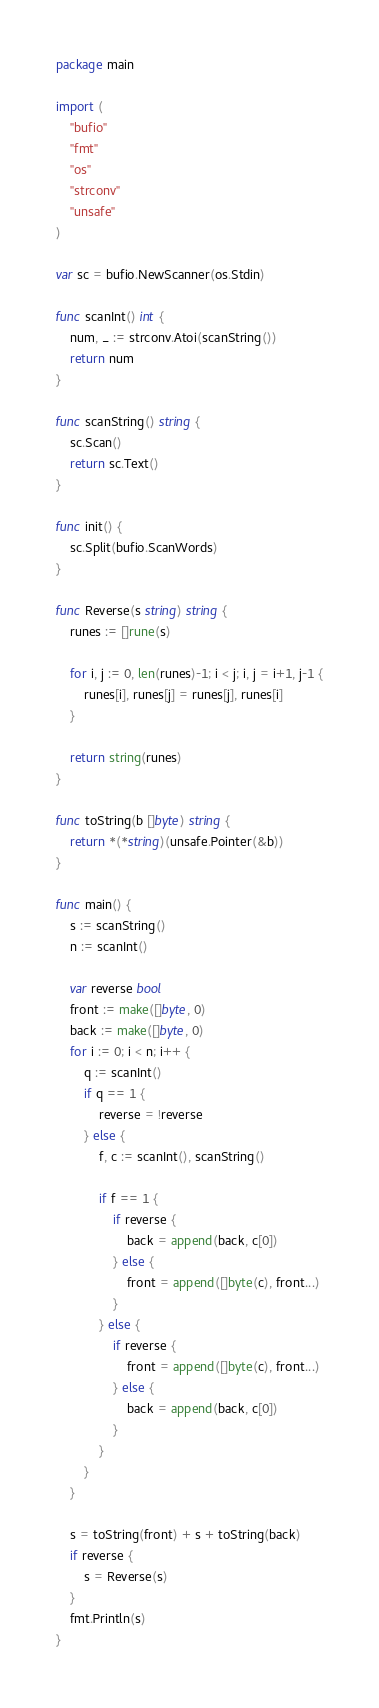Convert code to text. <code><loc_0><loc_0><loc_500><loc_500><_Go_>package main

import (
	"bufio"
	"fmt"
	"os"
	"strconv"
	"unsafe"
)

var sc = bufio.NewScanner(os.Stdin)

func scanInt() int {
	num, _ := strconv.Atoi(scanString())
	return num
}

func scanString() string {
	sc.Scan()
	return sc.Text()
}

func init() {
	sc.Split(bufio.ScanWords)
}

func Reverse(s string) string {
	runes := []rune(s)

	for i, j := 0, len(runes)-1; i < j; i, j = i+1, j-1 {
		runes[i], runes[j] = runes[j], runes[i]
	}

	return string(runes)
}

func toString(b []byte) string {
	return *(*string)(unsafe.Pointer(&b))
}

func main() {
	s := scanString()
	n := scanInt()

	var reverse bool
	front := make([]byte, 0)
	back := make([]byte, 0)
	for i := 0; i < n; i++ {
		q := scanInt()
		if q == 1 {
			reverse = !reverse
		} else {
			f, c := scanInt(), scanString()

			if f == 1 {
				if reverse {
					back = append(back, c[0])
				} else {
					front = append([]byte(c), front...)
				}
			} else {
				if reverse {
					front = append([]byte(c), front...)
				} else {
					back = append(back, c[0])
				}
			}
		}
	}

	s = toString(front) + s + toString(back)
	if reverse {
		s = Reverse(s)
	}
	fmt.Println(s)
}
</code> 